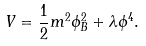Convert formula to latex. <formula><loc_0><loc_0><loc_500><loc_500>V = \frac { 1 } { 2 } m ^ { 2 } \phi _ { B } ^ { 2 } + \lambda \phi ^ { 4 } .</formula> 